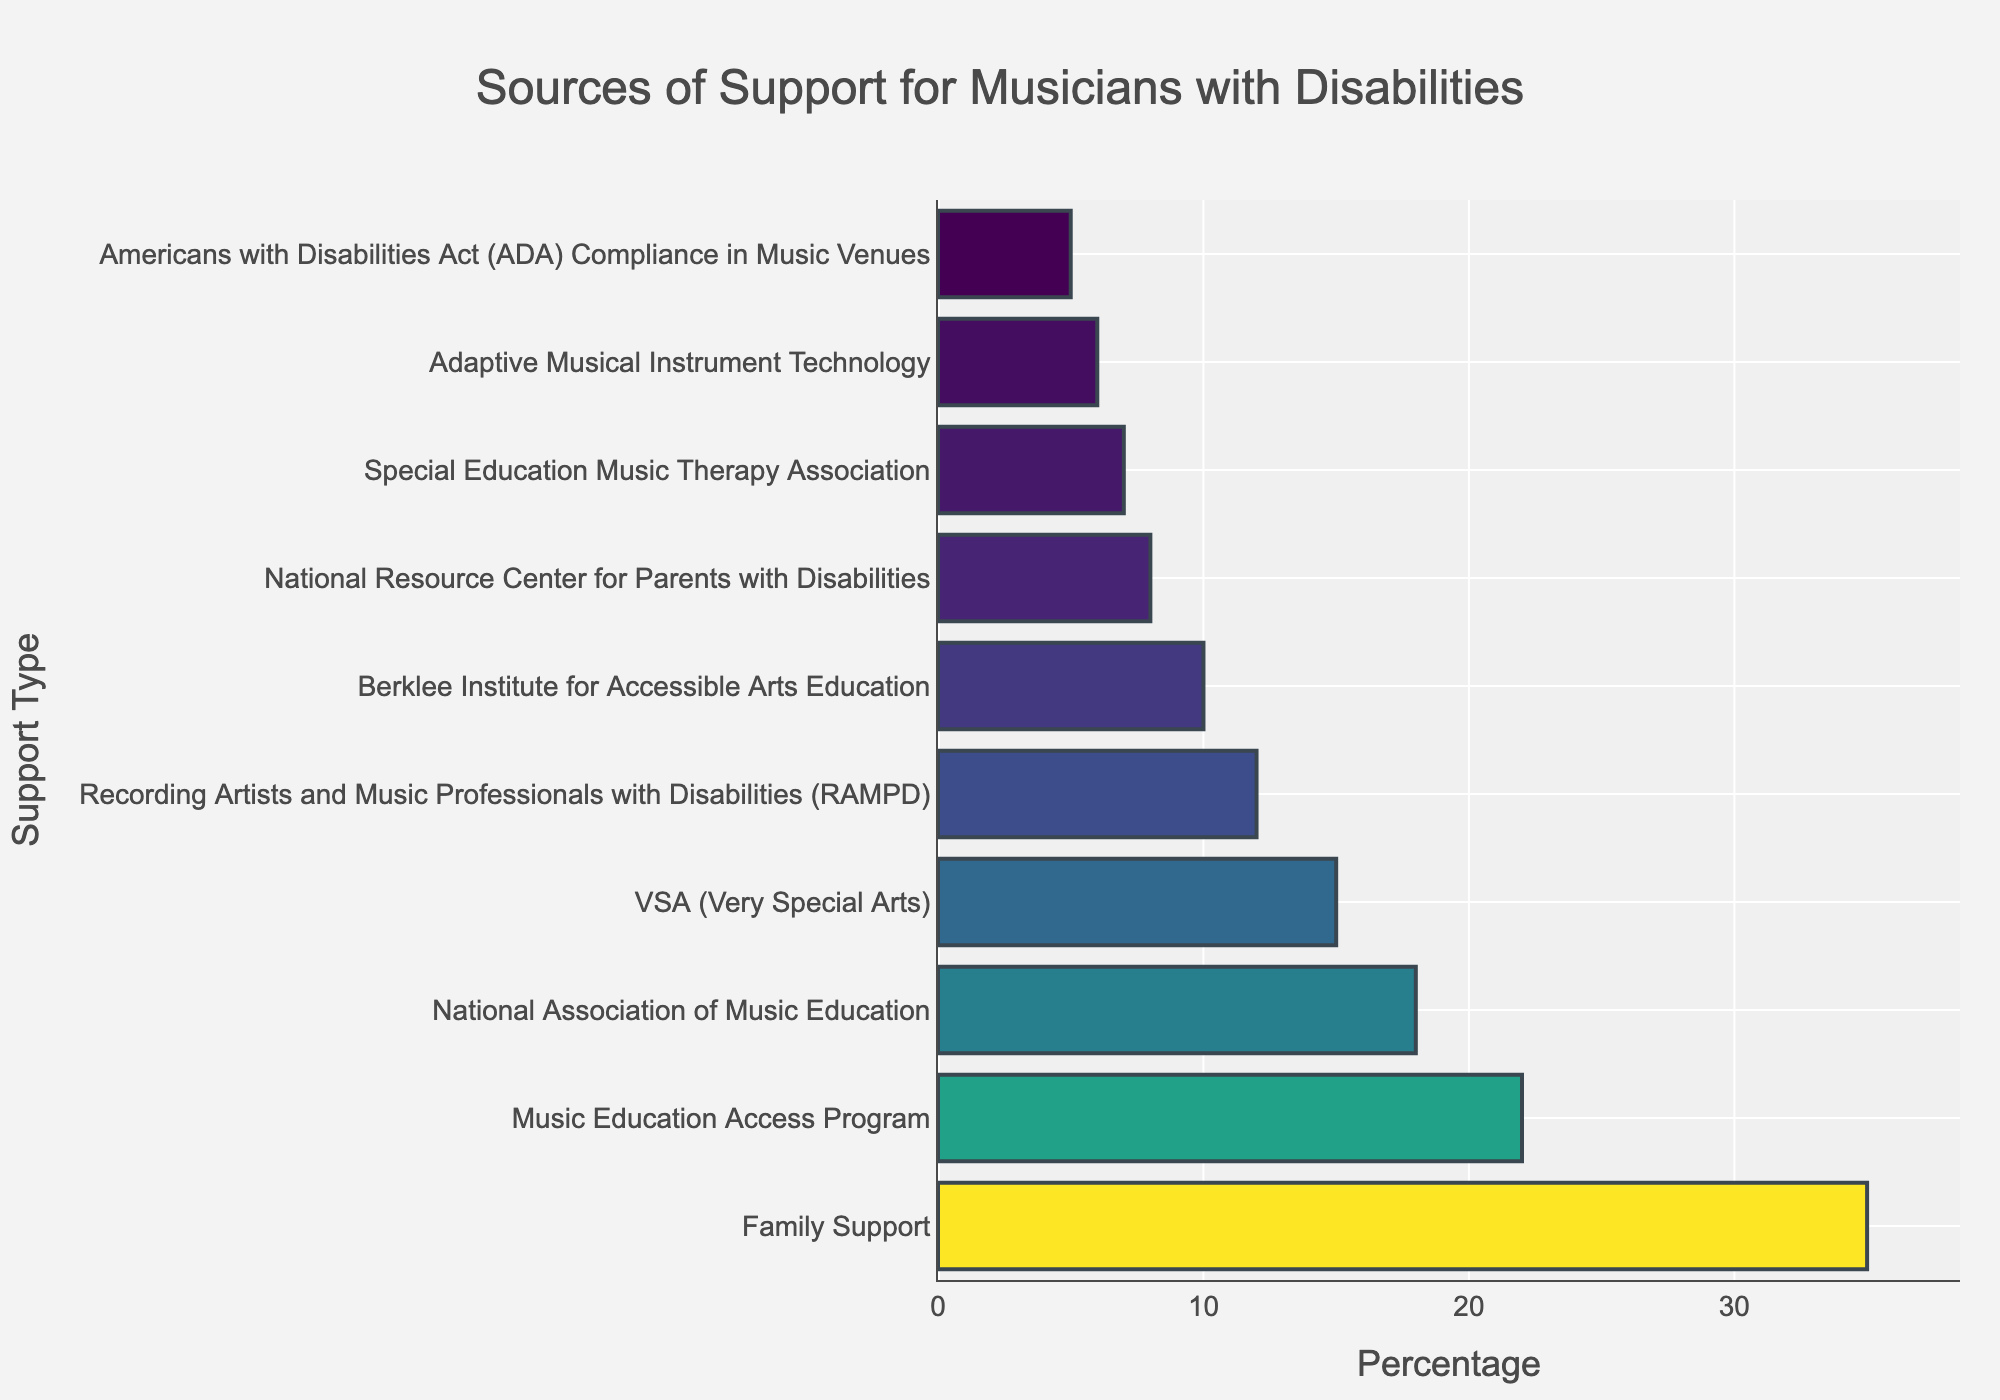How much more support is provided by family compared to the Berklee Institute for Accessible Arts Education? First, look at the percentages for Family Support (35%) and the Berklee Institute for Accessible Arts Education (10%). Calculate the difference by subtracting the latter from the former: 35 - 10 = 25
Answer: 25 Which source of support provides a higher percentage, VSA or RAMPD? Compare the percentages for VSA (15%) and RAMPD (12%). Since 15 is greater than 12, VSA provides a higher percentage.
Answer: VSA What is the combined percentage of support from the National Association of Music Education and Special Education Music Therapy Association? Look at the percentages for the National Association of Music Education (18%) and the Special Education Music Therapy Association (7%). Add them together: 18 + 7 = 25
Answer: 25 Is the support provided by Adaptive Musical Instrument Technology more or less than twice the support provided by the Americans with Disabilities Act (ADA) Compliance in Music Venues? The percentage for Adaptive Musical Instrument Technology is 6% and for ADA Compliance in Music Venues is 5%. Twice the ADA support is 5 * 2 = 10, which is more than 6, so the ADA provides less than twice.
Answer: Less Which source provides the least support? Look for the source with the smallest percentage. Americans with Disabilities Act (ADA) Compliance in Music Venues has the lowest percentage at 5%.
Answer: Americans with Disabilities Act (ADA) Compliance in Music Venues By how much does support from Music Education Access Program exceed support from Adaptive Musical Instrument Technology? Look at the percentages for Music Education Access Program (22%) and Adaptive Musical Instrument Technology (6%). Subtract the latter from the former: 22 - 6 = 16
Answer: 16 What is the range of support percentages across all sources? Find the difference between the highest percentage (Family Support at 35%) and the lowest percentage (Americans with Disabilities Act (ADA) Compliance in Music Venues at 5%): 35 - 5 = 30
Answer: 30 Which source has the closest support percentage to the median value of all listed sources? Calculate the median by first listing all percentages in ascending order: [5, 6, 7, 8, 10, 12, 15, 18, 22, 35]. The median is the middle value of this sorted list which is (10+12)/2 = 11. The source with a percentage closest to this value is RAMPD with 12%.
Answer: RAMPD What would be the new total percentage if the support from VSA and the National Resource Center for Parents with Disabilities is combined? Add the percentages for VSA (15%) and National Resource Center for Parents with Disabilities (8%): 15 + 8 = 23
Answer: 23 